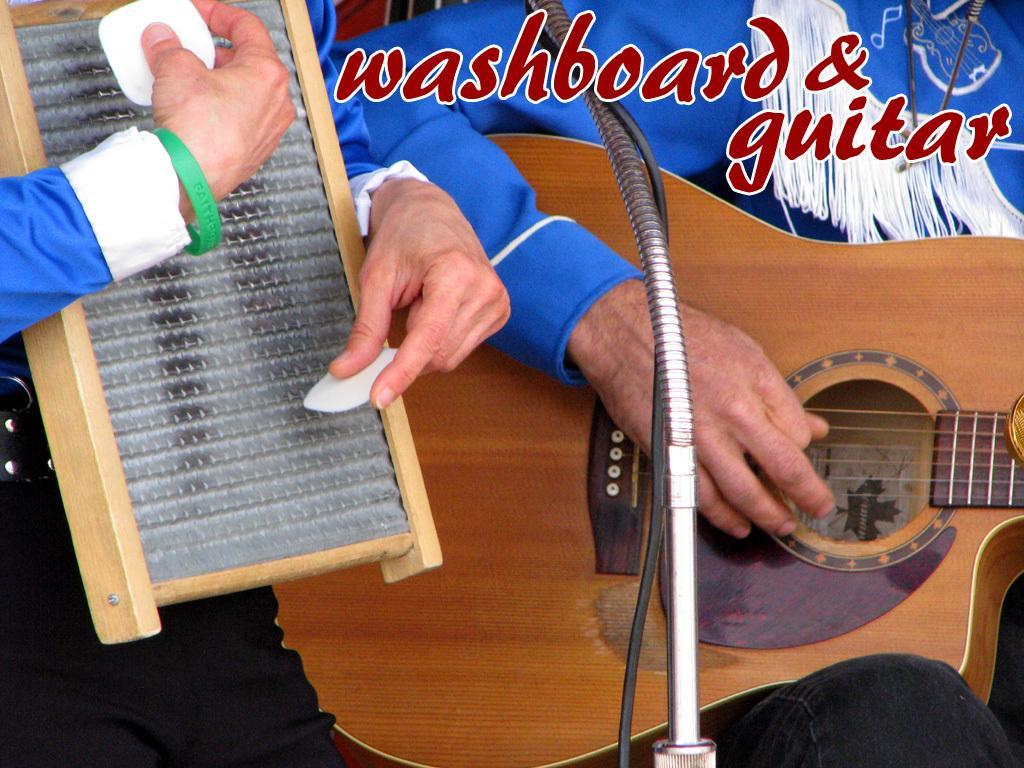Please provide a concise description of this image. In the image we can see there is a person who is standing and holding guitar in his hand. Another man is holding another musical instrument. 